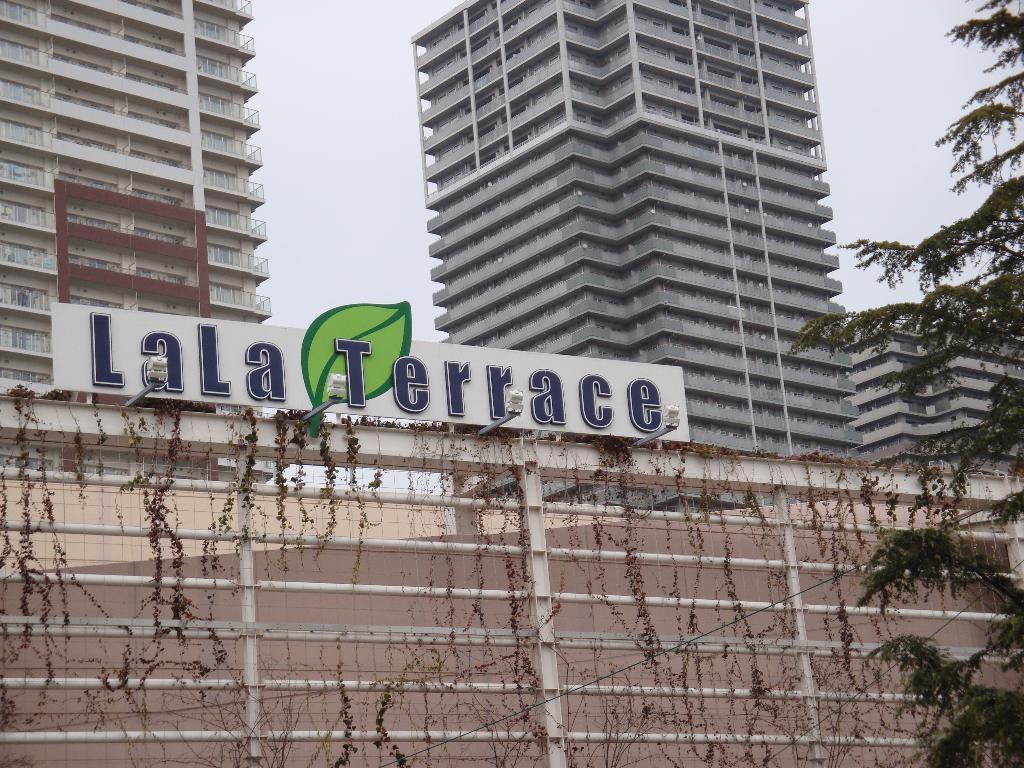How would you summarize this image in a sentence or two? In this image in front there is a metal fence. There is a board with letters on it. On the right side of the image there is a tree. In the background of the image there are buildings and sky. 